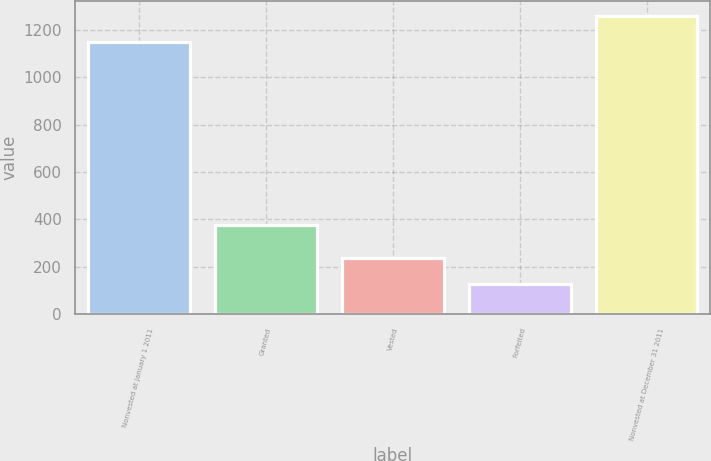Convert chart. <chart><loc_0><loc_0><loc_500><loc_500><bar_chart><fcel>Nonvested at January 1 2011<fcel>Granted<fcel>Vested<fcel>Forfeited<fcel>Nonvested at December 31 2011<nl><fcel>1151<fcel>376<fcel>235.6<fcel>128<fcel>1258.6<nl></chart> 